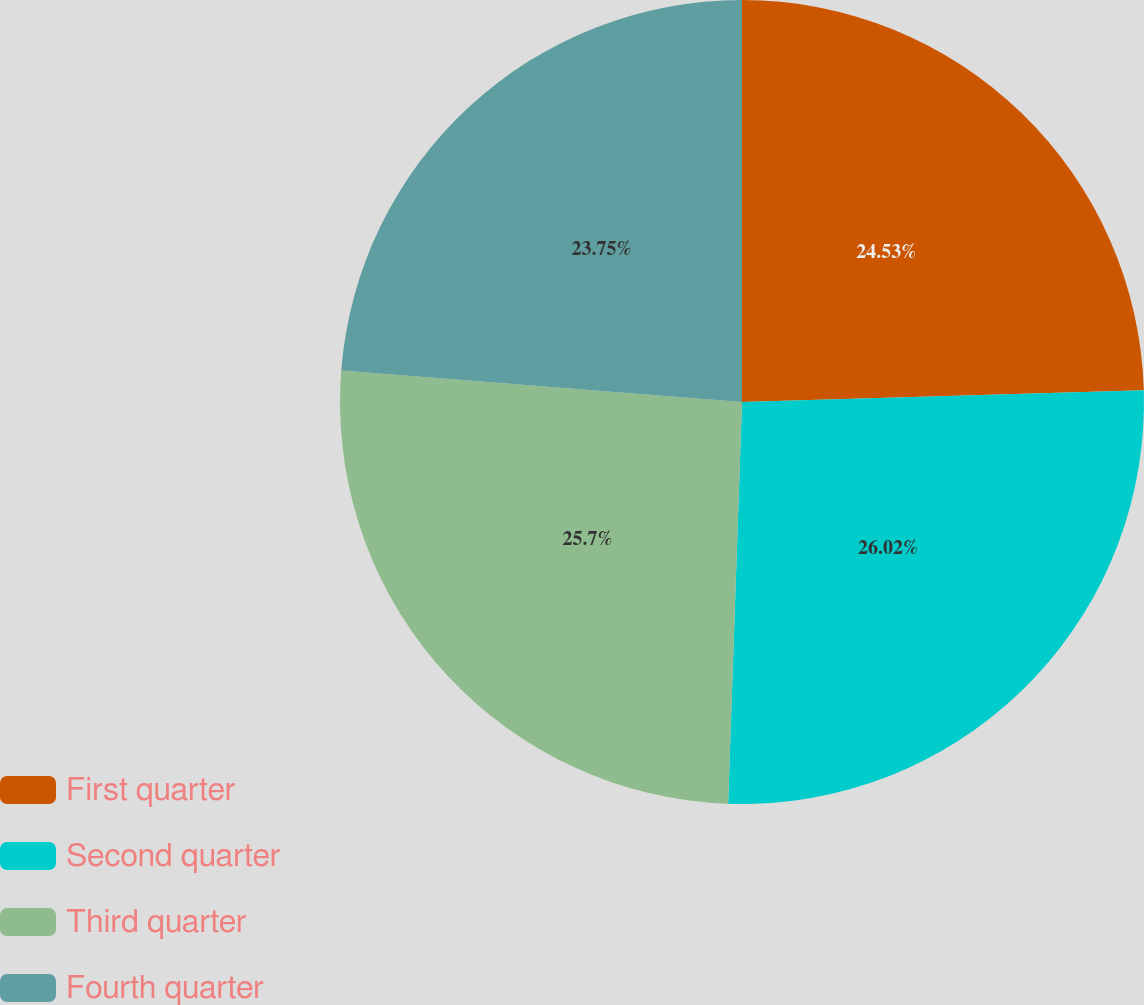Convert chart. <chart><loc_0><loc_0><loc_500><loc_500><pie_chart><fcel>First quarter<fcel>Second quarter<fcel>Third quarter<fcel>Fourth quarter<nl><fcel>24.53%<fcel>26.02%<fcel>25.7%<fcel>23.75%<nl></chart> 